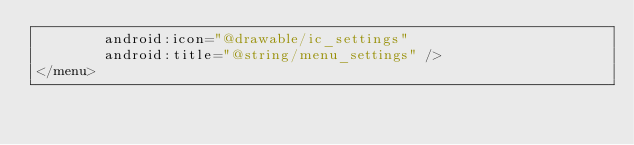Convert code to text. <code><loc_0><loc_0><loc_500><loc_500><_XML_>        android:icon="@drawable/ic_settings"
        android:title="@string/menu_settings" />
</menu></code> 